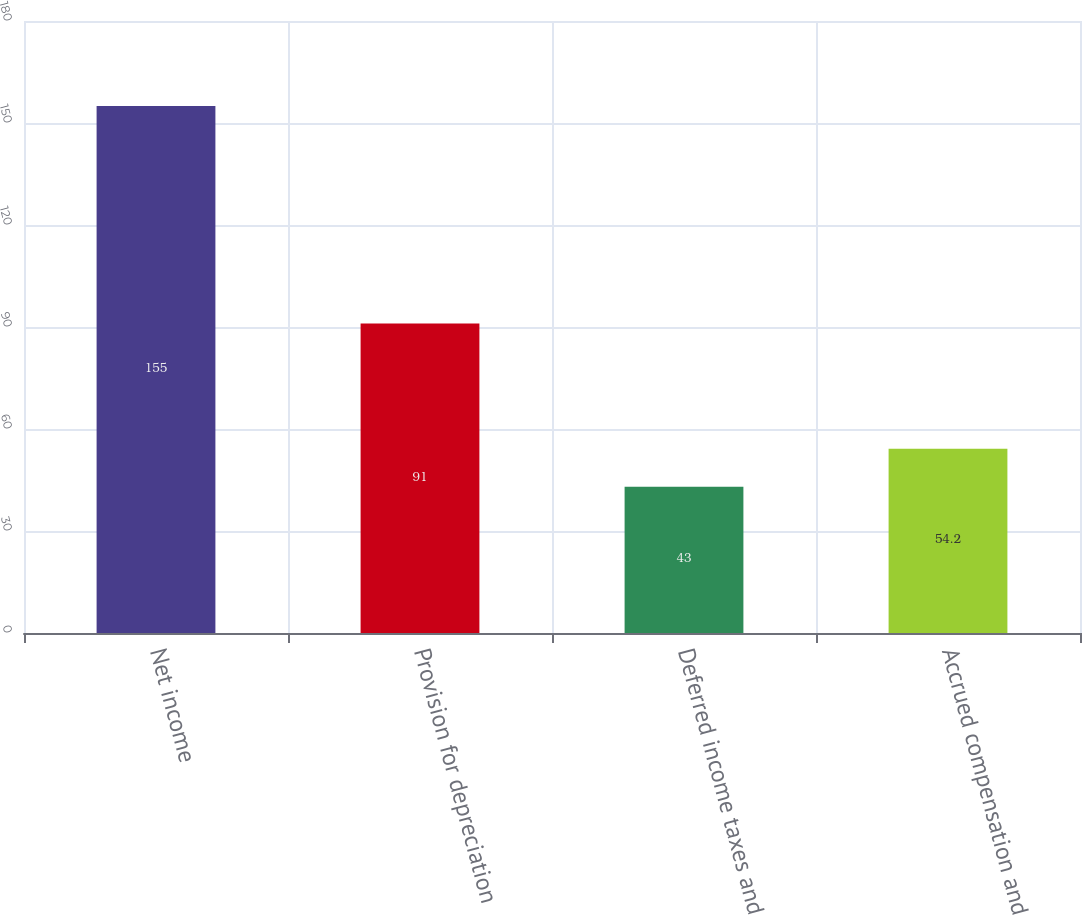Convert chart. <chart><loc_0><loc_0><loc_500><loc_500><bar_chart><fcel>Net income<fcel>Provision for depreciation<fcel>Deferred income taxes and<fcel>Accrued compensation and<nl><fcel>155<fcel>91<fcel>43<fcel>54.2<nl></chart> 